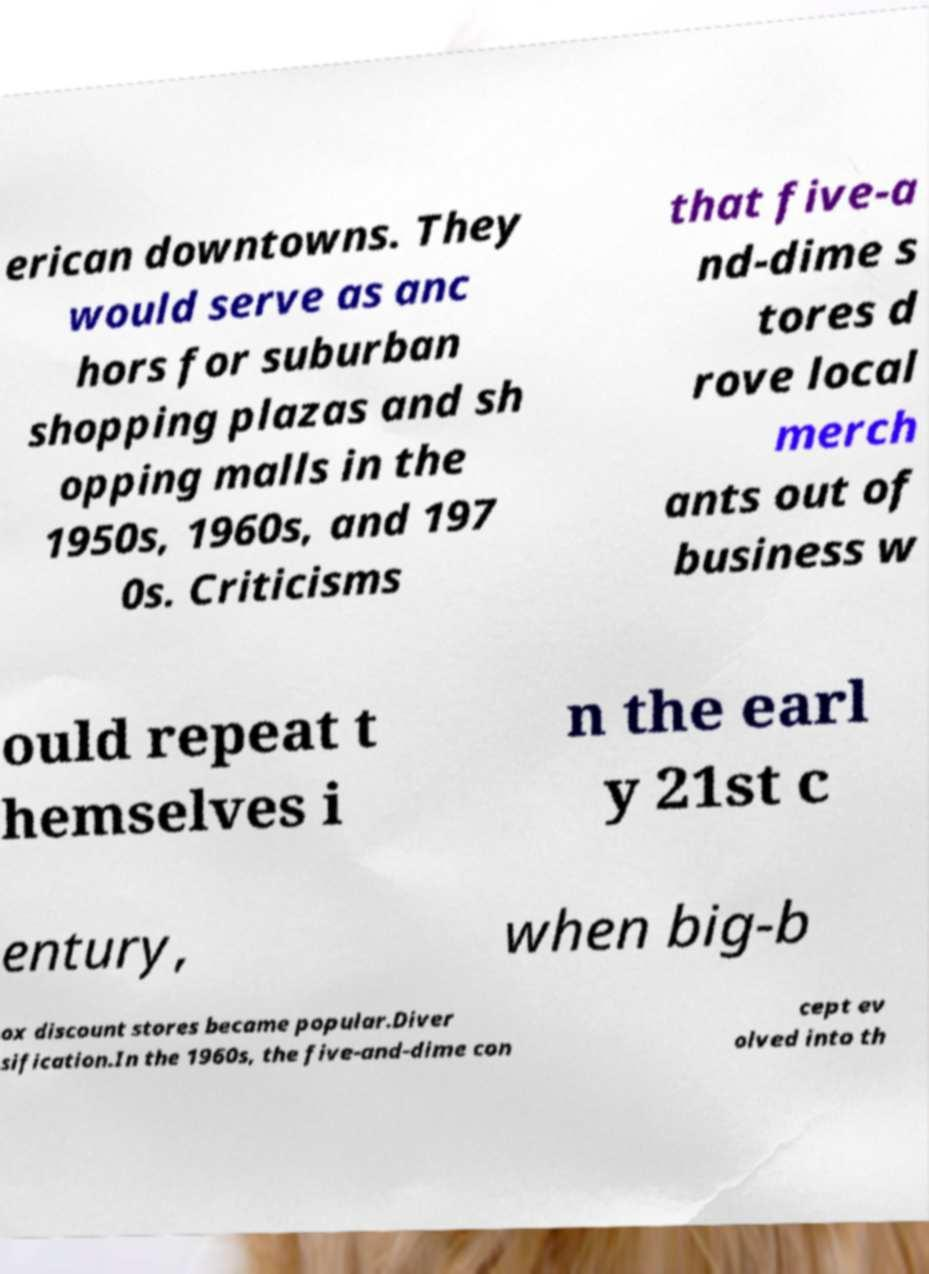I need the written content from this picture converted into text. Can you do that? erican downtowns. They would serve as anc hors for suburban shopping plazas and sh opping malls in the 1950s, 1960s, and 197 0s. Criticisms that five-a nd-dime s tores d rove local merch ants out of business w ould repeat t hemselves i n the earl y 21st c entury, when big-b ox discount stores became popular.Diver sification.In the 1960s, the five-and-dime con cept ev olved into th 